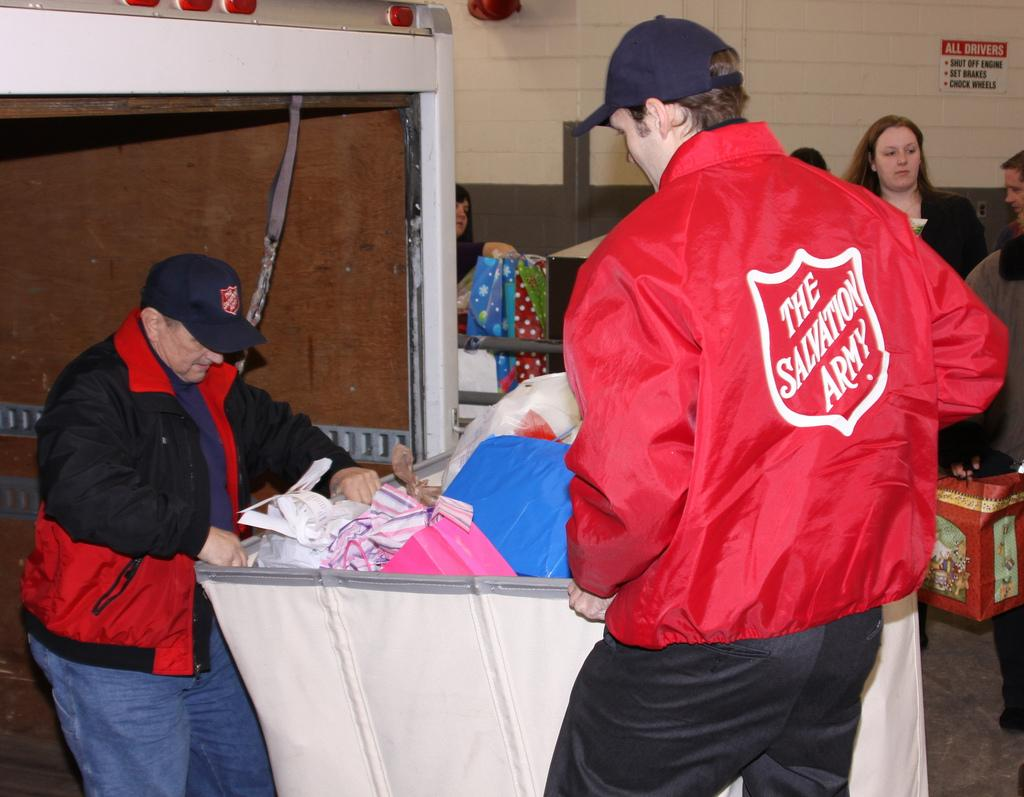Provide a one-sentence caption for the provided image. Two Salvation Army workers push a cart containing donated items in a receiving area. 